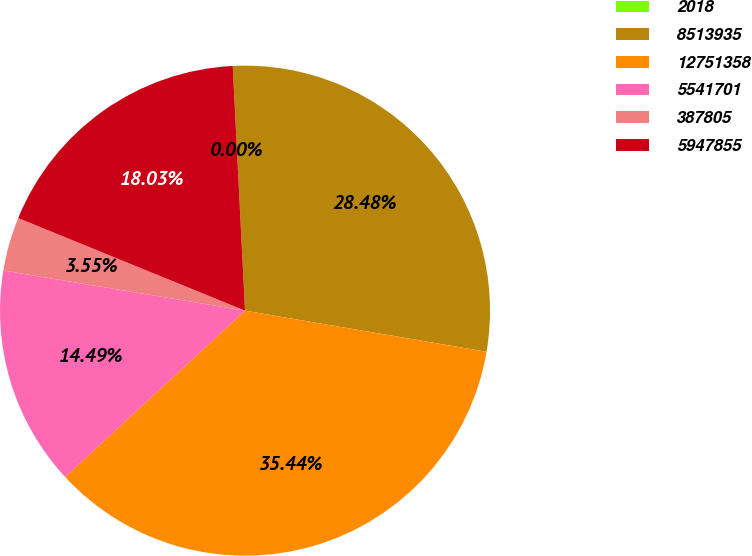<chart> <loc_0><loc_0><loc_500><loc_500><pie_chart><fcel>2018<fcel>8513935<fcel>12751358<fcel>5541701<fcel>387805<fcel>5947855<nl><fcel>0.0%<fcel>28.48%<fcel>35.44%<fcel>14.49%<fcel>3.55%<fcel>18.03%<nl></chart> 